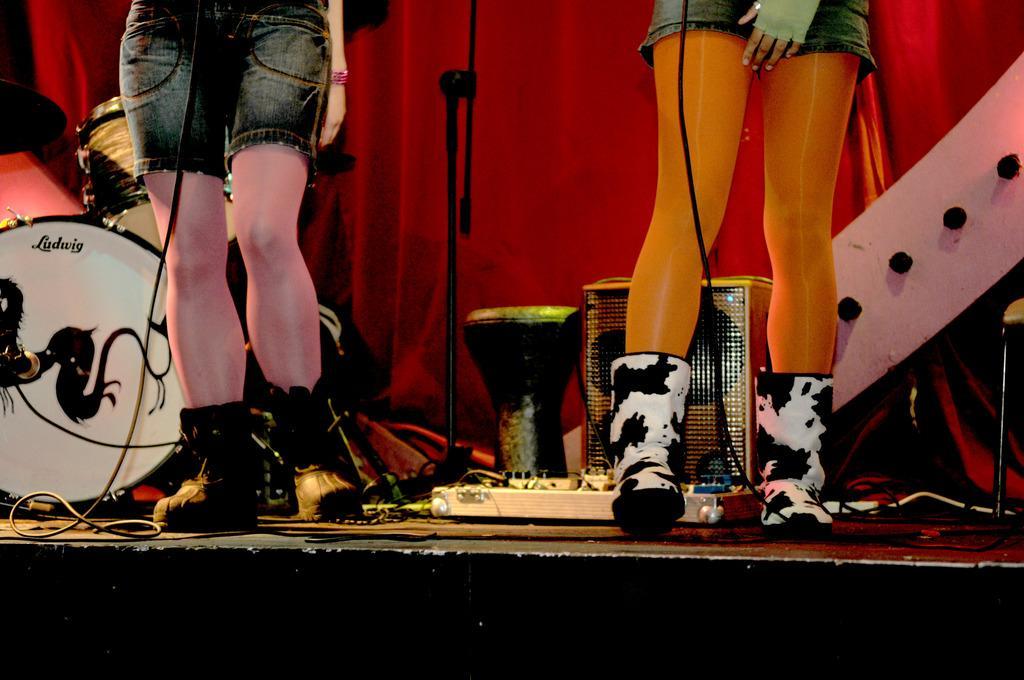How would you summarize this image in a sentence or two? In this image in the center there are persons standing. In the background there are musical instruments, there is a stand in the center and in the background there is a curtain which is red in colour. 